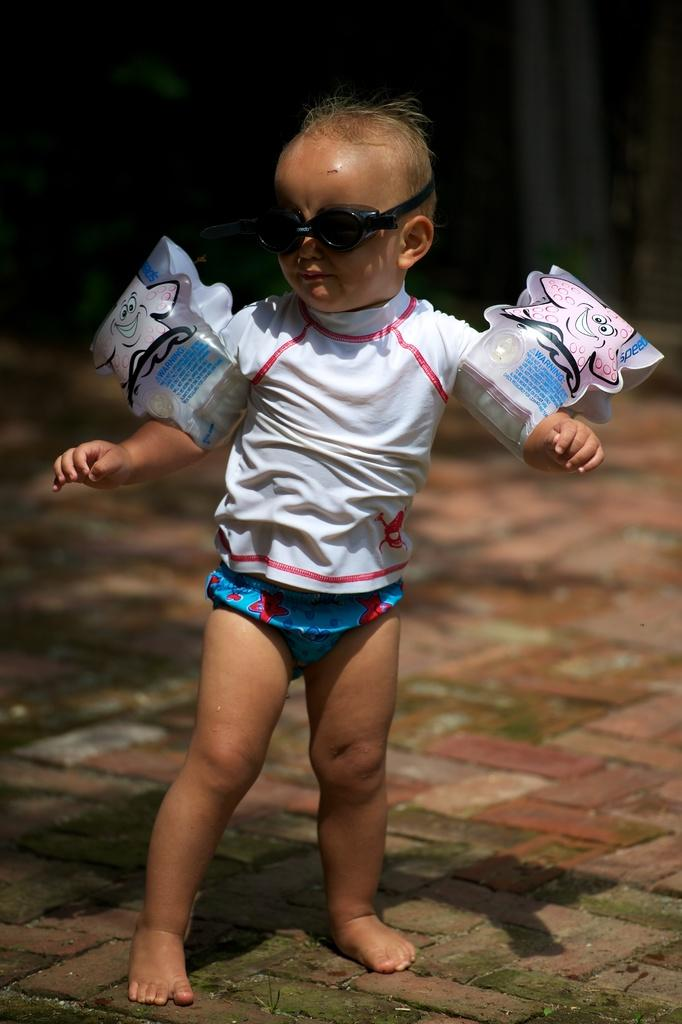What is the main subject of the image? The main subject of the image is a kid. Where is the kid located in the image? The kid is standing on the floor in the image. What is the kid wearing in the image? The kid is wearing goggles in the image. Can you describe the background of the image? The background of the image is blurry. What type of pets are being covered by the kid in the image? There are no pets present in the image, and the kid is not covering anything. What is the end result of the kid's actions in the image? The image does not depict any actions or end results; it simply shows a kid standing on the floor wearing goggles. 